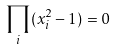<formula> <loc_0><loc_0><loc_500><loc_500>\prod _ { i } ( x _ { i } ^ { 2 } - 1 ) = 0</formula> 